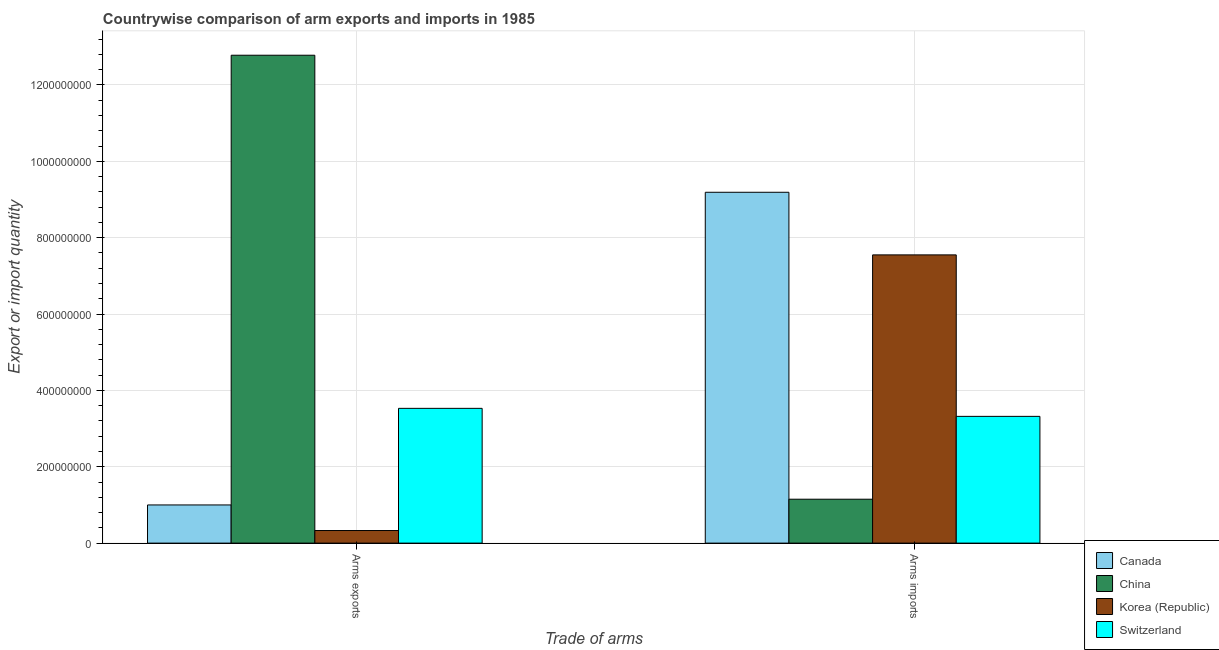How many different coloured bars are there?
Offer a terse response. 4. How many groups of bars are there?
Provide a short and direct response. 2. Are the number of bars per tick equal to the number of legend labels?
Make the answer very short. Yes. How many bars are there on the 1st tick from the left?
Keep it short and to the point. 4. How many bars are there on the 2nd tick from the right?
Offer a very short reply. 4. What is the label of the 2nd group of bars from the left?
Your response must be concise. Arms imports. What is the arms imports in Canada?
Provide a short and direct response. 9.19e+08. Across all countries, what is the maximum arms exports?
Your response must be concise. 1.28e+09. Across all countries, what is the minimum arms exports?
Provide a succinct answer. 3.30e+07. In which country was the arms exports maximum?
Give a very brief answer. China. What is the total arms exports in the graph?
Make the answer very short. 1.76e+09. What is the difference between the arms imports in China and that in Korea (Republic)?
Your answer should be very brief. -6.40e+08. What is the difference between the arms imports in China and the arms exports in Switzerland?
Provide a short and direct response. -2.38e+08. What is the average arms imports per country?
Give a very brief answer. 5.30e+08. What is the difference between the arms exports and arms imports in Switzerland?
Offer a very short reply. 2.10e+07. In how many countries, is the arms exports greater than 1200000000 ?
Your response must be concise. 1. What is the ratio of the arms imports in Switzerland to that in Canada?
Ensure brevity in your answer.  0.36. What does the 1st bar from the left in Arms imports represents?
Provide a short and direct response. Canada. What does the 2nd bar from the right in Arms exports represents?
Offer a very short reply. Korea (Republic). Are all the bars in the graph horizontal?
Your answer should be compact. No. Are the values on the major ticks of Y-axis written in scientific E-notation?
Your answer should be very brief. No. Does the graph contain any zero values?
Your answer should be very brief. No. Does the graph contain grids?
Your answer should be compact. Yes. How are the legend labels stacked?
Your response must be concise. Vertical. What is the title of the graph?
Provide a short and direct response. Countrywise comparison of arm exports and imports in 1985. What is the label or title of the X-axis?
Provide a short and direct response. Trade of arms. What is the label or title of the Y-axis?
Provide a short and direct response. Export or import quantity. What is the Export or import quantity of China in Arms exports?
Give a very brief answer. 1.28e+09. What is the Export or import quantity in Korea (Republic) in Arms exports?
Offer a terse response. 3.30e+07. What is the Export or import quantity of Switzerland in Arms exports?
Keep it short and to the point. 3.53e+08. What is the Export or import quantity in Canada in Arms imports?
Offer a terse response. 9.19e+08. What is the Export or import quantity of China in Arms imports?
Your answer should be compact. 1.15e+08. What is the Export or import quantity of Korea (Republic) in Arms imports?
Keep it short and to the point. 7.55e+08. What is the Export or import quantity of Switzerland in Arms imports?
Provide a succinct answer. 3.32e+08. Across all Trade of arms, what is the maximum Export or import quantity in Canada?
Make the answer very short. 9.19e+08. Across all Trade of arms, what is the maximum Export or import quantity in China?
Offer a very short reply. 1.28e+09. Across all Trade of arms, what is the maximum Export or import quantity of Korea (Republic)?
Make the answer very short. 7.55e+08. Across all Trade of arms, what is the maximum Export or import quantity in Switzerland?
Provide a succinct answer. 3.53e+08. Across all Trade of arms, what is the minimum Export or import quantity in Canada?
Your response must be concise. 1.00e+08. Across all Trade of arms, what is the minimum Export or import quantity in China?
Your response must be concise. 1.15e+08. Across all Trade of arms, what is the minimum Export or import quantity of Korea (Republic)?
Ensure brevity in your answer.  3.30e+07. Across all Trade of arms, what is the minimum Export or import quantity of Switzerland?
Offer a very short reply. 3.32e+08. What is the total Export or import quantity in Canada in the graph?
Your answer should be very brief. 1.02e+09. What is the total Export or import quantity in China in the graph?
Provide a short and direct response. 1.39e+09. What is the total Export or import quantity of Korea (Republic) in the graph?
Make the answer very short. 7.88e+08. What is the total Export or import quantity of Switzerland in the graph?
Make the answer very short. 6.85e+08. What is the difference between the Export or import quantity in Canada in Arms exports and that in Arms imports?
Your response must be concise. -8.19e+08. What is the difference between the Export or import quantity of China in Arms exports and that in Arms imports?
Offer a very short reply. 1.16e+09. What is the difference between the Export or import quantity of Korea (Republic) in Arms exports and that in Arms imports?
Keep it short and to the point. -7.22e+08. What is the difference between the Export or import quantity of Switzerland in Arms exports and that in Arms imports?
Keep it short and to the point. 2.10e+07. What is the difference between the Export or import quantity of Canada in Arms exports and the Export or import quantity of China in Arms imports?
Your answer should be very brief. -1.50e+07. What is the difference between the Export or import quantity of Canada in Arms exports and the Export or import quantity of Korea (Republic) in Arms imports?
Your answer should be very brief. -6.55e+08. What is the difference between the Export or import quantity of Canada in Arms exports and the Export or import quantity of Switzerland in Arms imports?
Make the answer very short. -2.32e+08. What is the difference between the Export or import quantity in China in Arms exports and the Export or import quantity in Korea (Republic) in Arms imports?
Keep it short and to the point. 5.23e+08. What is the difference between the Export or import quantity of China in Arms exports and the Export or import quantity of Switzerland in Arms imports?
Offer a very short reply. 9.46e+08. What is the difference between the Export or import quantity of Korea (Republic) in Arms exports and the Export or import quantity of Switzerland in Arms imports?
Give a very brief answer. -2.99e+08. What is the average Export or import quantity of Canada per Trade of arms?
Make the answer very short. 5.10e+08. What is the average Export or import quantity in China per Trade of arms?
Make the answer very short. 6.96e+08. What is the average Export or import quantity of Korea (Republic) per Trade of arms?
Offer a very short reply. 3.94e+08. What is the average Export or import quantity of Switzerland per Trade of arms?
Keep it short and to the point. 3.42e+08. What is the difference between the Export or import quantity in Canada and Export or import quantity in China in Arms exports?
Give a very brief answer. -1.18e+09. What is the difference between the Export or import quantity of Canada and Export or import quantity of Korea (Republic) in Arms exports?
Your answer should be compact. 6.70e+07. What is the difference between the Export or import quantity in Canada and Export or import quantity in Switzerland in Arms exports?
Provide a short and direct response. -2.53e+08. What is the difference between the Export or import quantity in China and Export or import quantity in Korea (Republic) in Arms exports?
Your answer should be compact. 1.24e+09. What is the difference between the Export or import quantity in China and Export or import quantity in Switzerland in Arms exports?
Keep it short and to the point. 9.25e+08. What is the difference between the Export or import quantity of Korea (Republic) and Export or import quantity of Switzerland in Arms exports?
Provide a short and direct response. -3.20e+08. What is the difference between the Export or import quantity of Canada and Export or import quantity of China in Arms imports?
Keep it short and to the point. 8.04e+08. What is the difference between the Export or import quantity of Canada and Export or import quantity of Korea (Republic) in Arms imports?
Your answer should be very brief. 1.64e+08. What is the difference between the Export or import quantity of Canada and Export or import quantity of Switzerland in Arms imports?
Your answer should be very brief. 5.87e+08. What is the difference between the Export or import quantity of China and Export or import quantity of Korea (Republic) in Arms imports?
Provide a short and direct response. -6.40e+08. What is the difference between the Export or import quantity in China and Export or import quantity in Switzerland in Arms imports?
Ensure brevity in your answer.  -2.17e+08. What is the difference between the Export or import quantity in Korea (Republic) and Export or import quantity in Switzerland in Arms imports?
Give a very brief answer. 4.23e+08. What is the ratio of the Export or import quantity of Canada in Arms exports to that in Arms imports?
Offer a very short reply. 0.11. What is the ratio of the Export or import quantity of China in Arms exports to that in Arms imports?
Keep it short and to the point. 11.11. What is the ratio of the Export or import quantity in Korea (Republic) in Arms exports to that in Arms imports?
Offer a very short reply. 0.04. What is the ratio of the Export or import quantity in Switzerland in Arms exports to that in Arms imports?
Offer a terse response. 1.06. What is the difference between the highest and the second highest Export or import quantity in Canada?
Your answer should be compact. 8.19e+08. What is the difference between the highest and the second highest Export or import quantity in China?
Ensure brevity in your answer.  1.16e+09. What is the difference between the highest and the second highest Export or import quantity of Korea (Republic)?
Ensure brevity in your answer.  7.22e+08. What is the difference between the highest and the second highest Export or import quantity in Switzerland?
Provide a succinct answer. 2.10e+07. What is the difference between the highest and the lowest Export or import quantity of Canada?
Give a very brief answer. 8.19e+08. What is the difference between the highest and the lowest Export or import quantity of China?
Offer a very short reply. 1.16e+09. What is the difference between the highest and the lowest Export or import quantity of Korea (Republic)?
Provide a short and direct response. 7.22e+08. What is the difference between the highest and the lowest Export or import quantity of Switzerland?
Keep it short and to the point. 2.10e+07. 